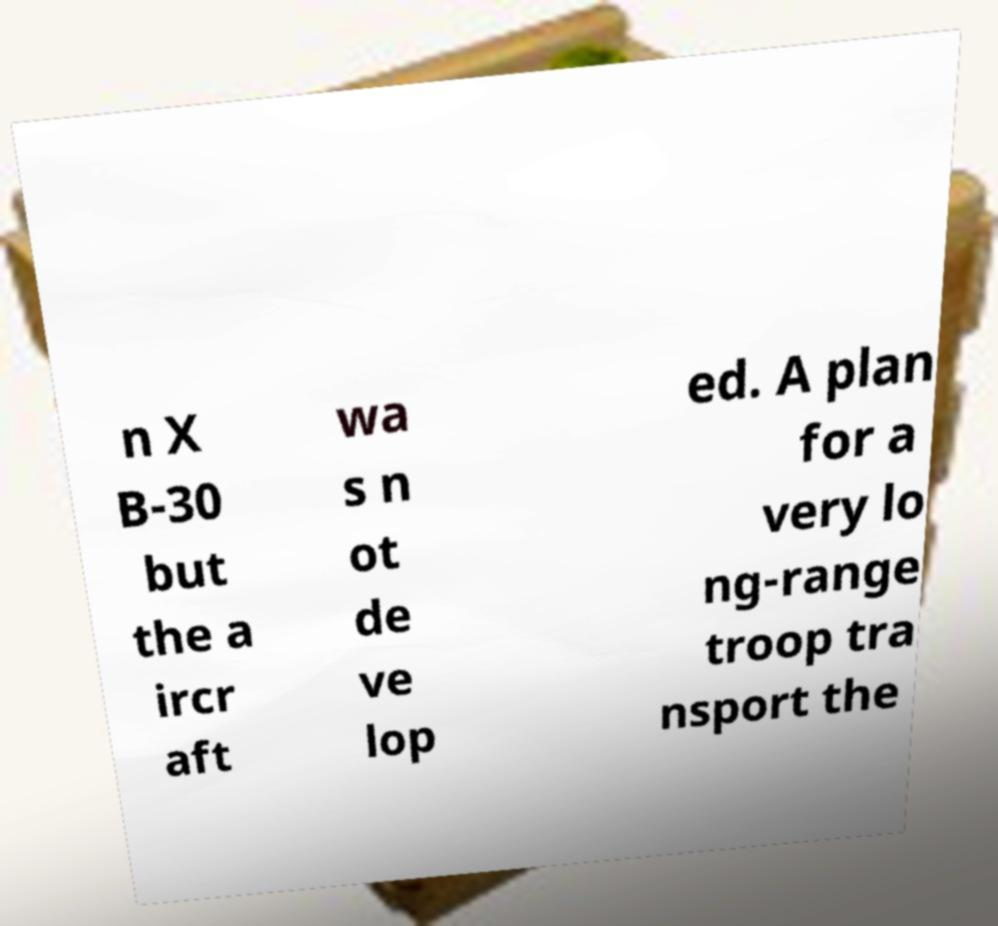Please read and relay the text visible in this image. What does it say? n X B-30 but the a ircr aft wa s n ot de ve lop ed. A plan for a very lo ng-range troop tra nsport the 